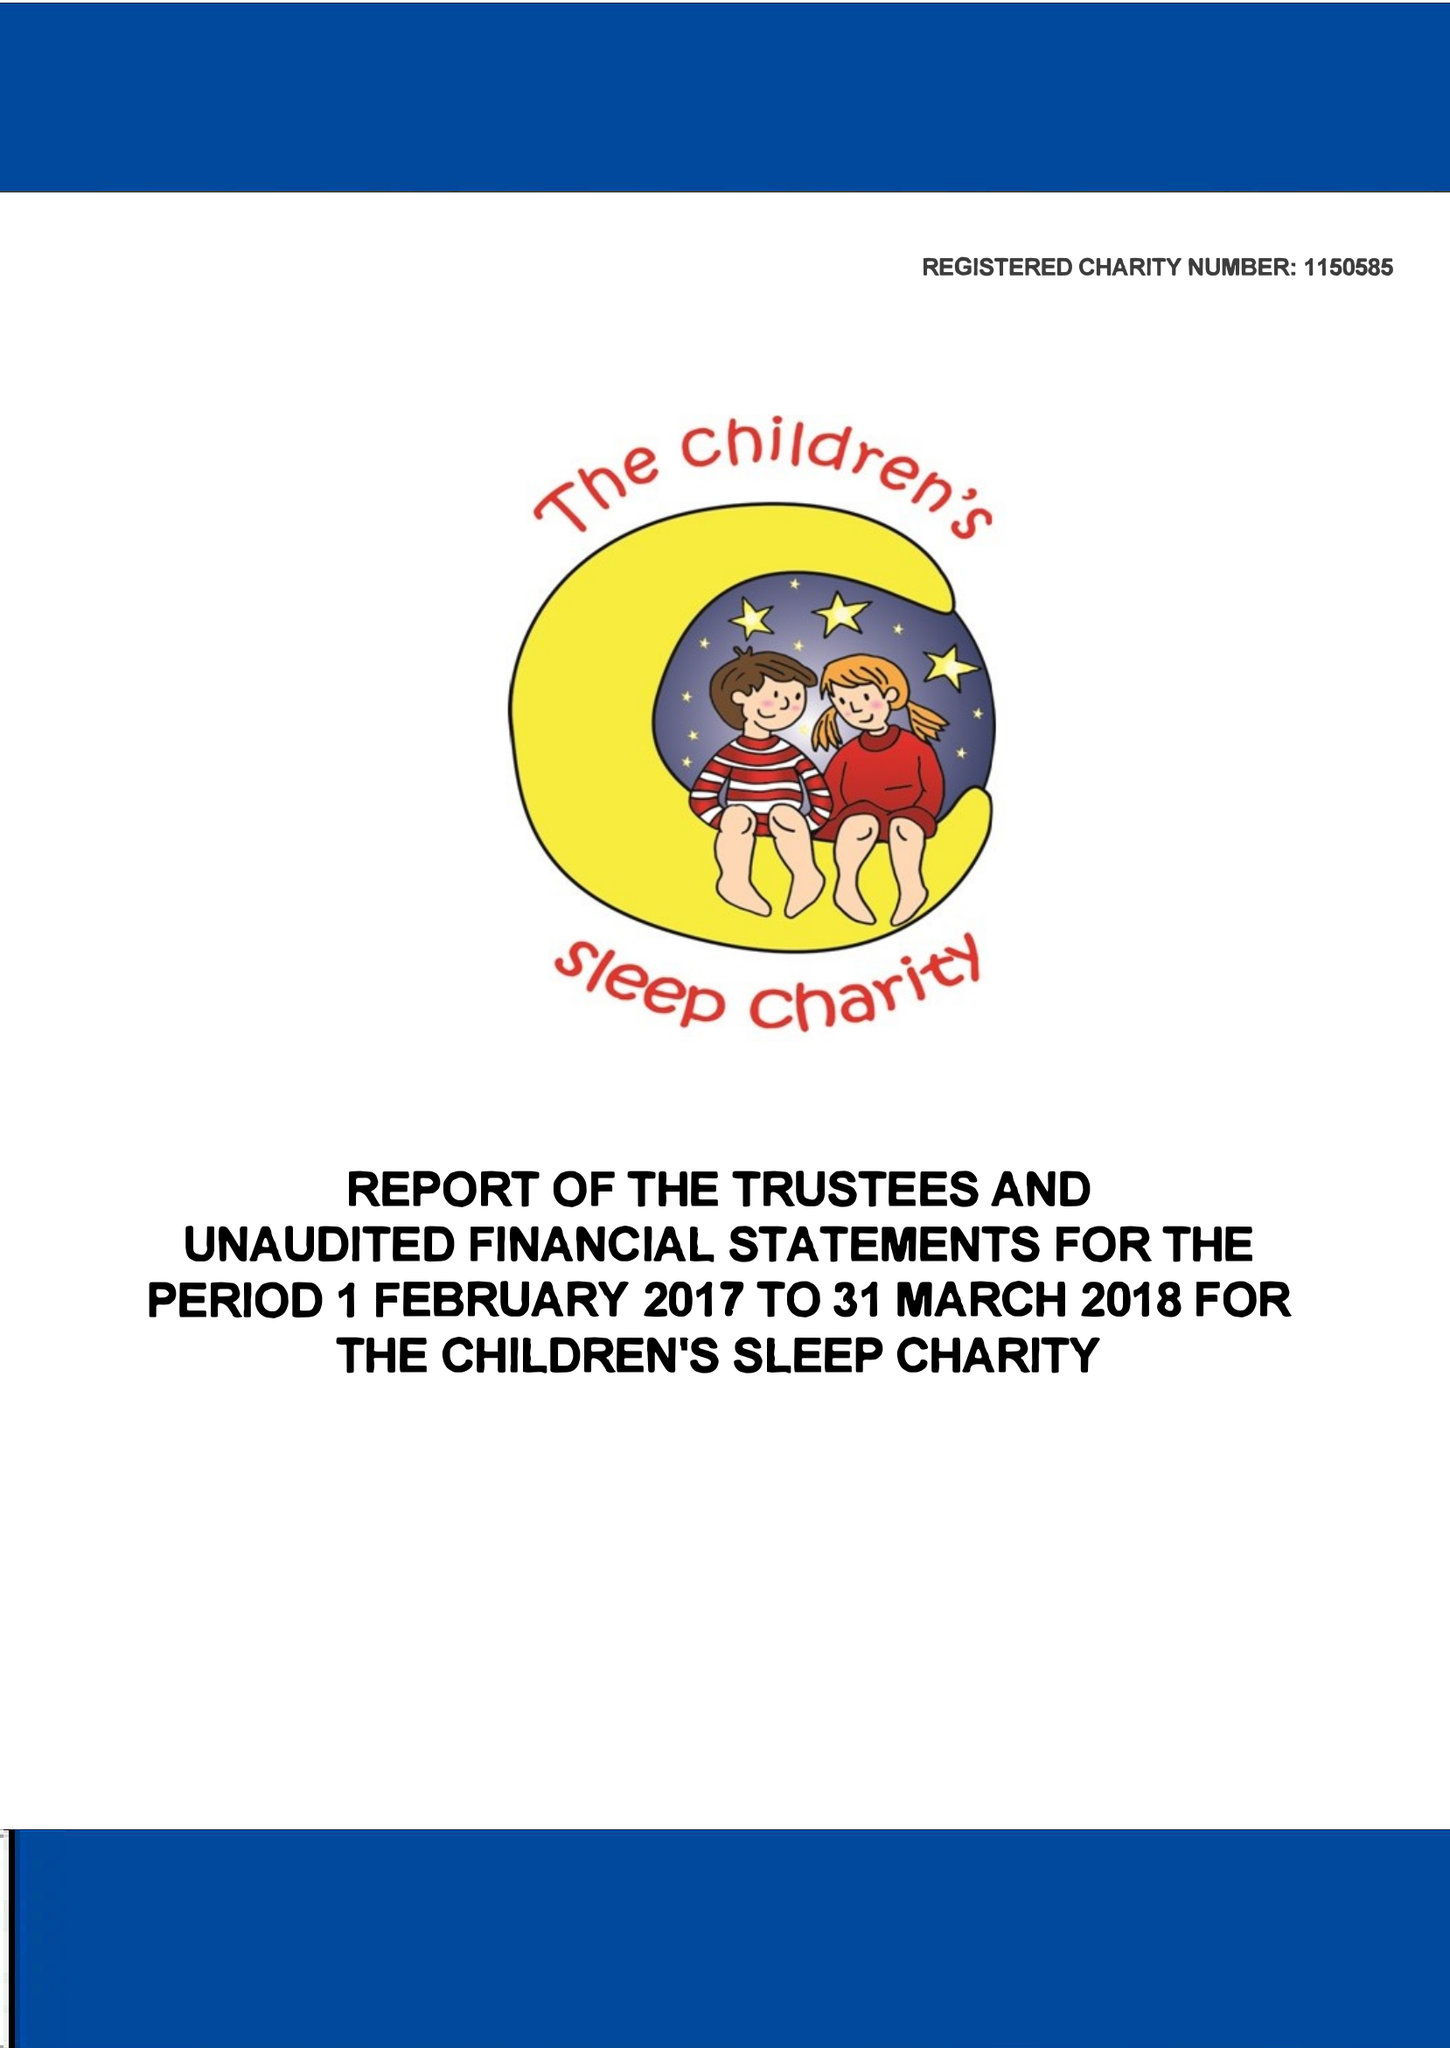What is the value for the report_date?
Answer the question using a single word or phrase. 2018-03-31 